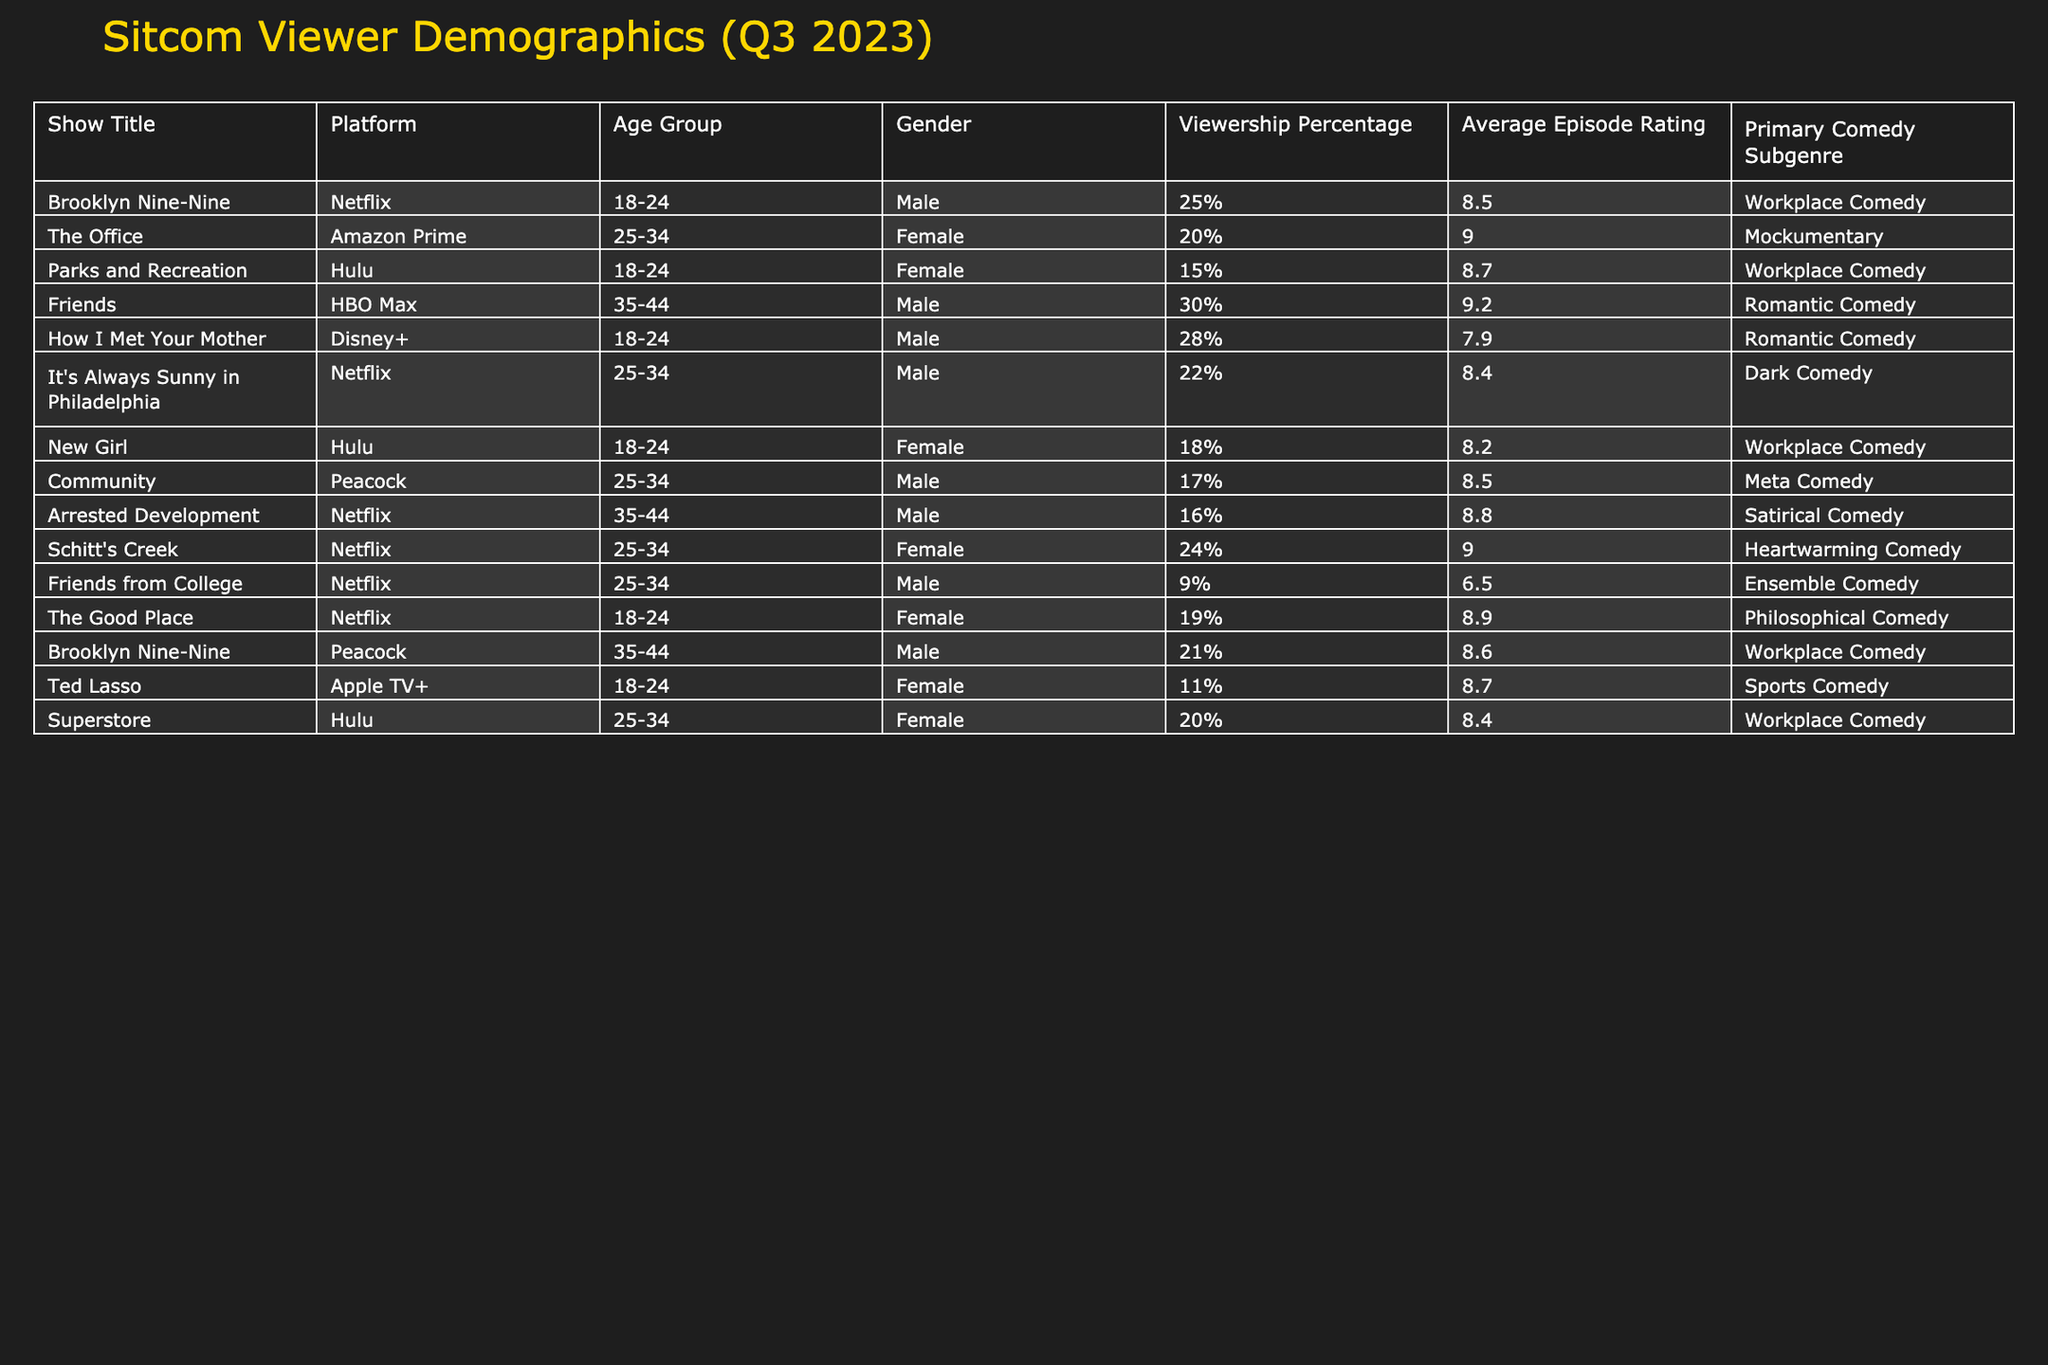What is the viewership percentage for "Friends"? According to the table, "Friends" has a viewership percentage of 30% in the demographic of males aged 35-44.
Answer: 30% Which sitcom has the highest average episode rating? By reviewing the ratings in the table, "Friends" has the highest average episode rating at 9.2.
Answer: 9.2 How many sitcoms have a viewership percentage greater than 20%? There are five sitcoms with a viewership percentage greater than 20%: "Brooklyn Nine-Nine" (25%), "How I Met Your Mother" (28%), "It's Always Sunny in Philadelphia" (22%), "Schitt's Creek" (24%), and "Brooklyn Nine-Nine" (21%). Therefore, the count is 5.
Answer: 5 Is "Parks and Recreation" classified as a Romantic Comedy? The table specifies that "Parks and Recreation" falls under the category of Workplace Comedy, not Romantic Comedy.
Answer: No What is the average rating of sitcoms targeted at the 18-24 age group? The ratings for the 18-24 age group sitcoms are: "Brooklyn Nine-Nine" (8.5), "Parks and Recreation" (8.7), "New Girl" (8.2), "The Good Place" (8.9), and "How I Met Your Mother" (7.9). Adding these ratings totals 41.2. The average is calculated as 41.2 divided by 5, which equals 8.24.
Answer: 8.24 What percentage of viewers aged 25-34 prefer sitcoms featuring female leads? Looking at the data for the 25-34 age group, the sitcoms are "The Office" (20%), "It's Always Sunny in Philadelphia" (22%), "Schitt's Creek" (24%), and "Superstore" (20%). Among these, "The Office" and "Schitt's Creek" feature female leads, providing a count of 2. The percentage is therefore (2/4)*100 = 50%.
Answer: 50% Which platform has the most sitcoms aimed at the 18-24 age group? Reviewing the table shows that Netflix has three sitcoms targeted at the 18-24 age group: "Brooklyn Nine-Nine," "The Good Place," and "How I Met Your Mother." Hulu has one sitcom in that age group. Therefore, Netflix has the most.
Answer: Netflix Can you identify a sitcom with a lower rating than "Friends from College"? "Friends from College" has a rating of 6.5. Looking at other sitcoms, "Friends from College" is rated lower than "Ted Lasso" (8.7) and "New Girl" (8.2). Therefore, yes, there are sitcoms lower than "Friends from College."
Answer: Yes 